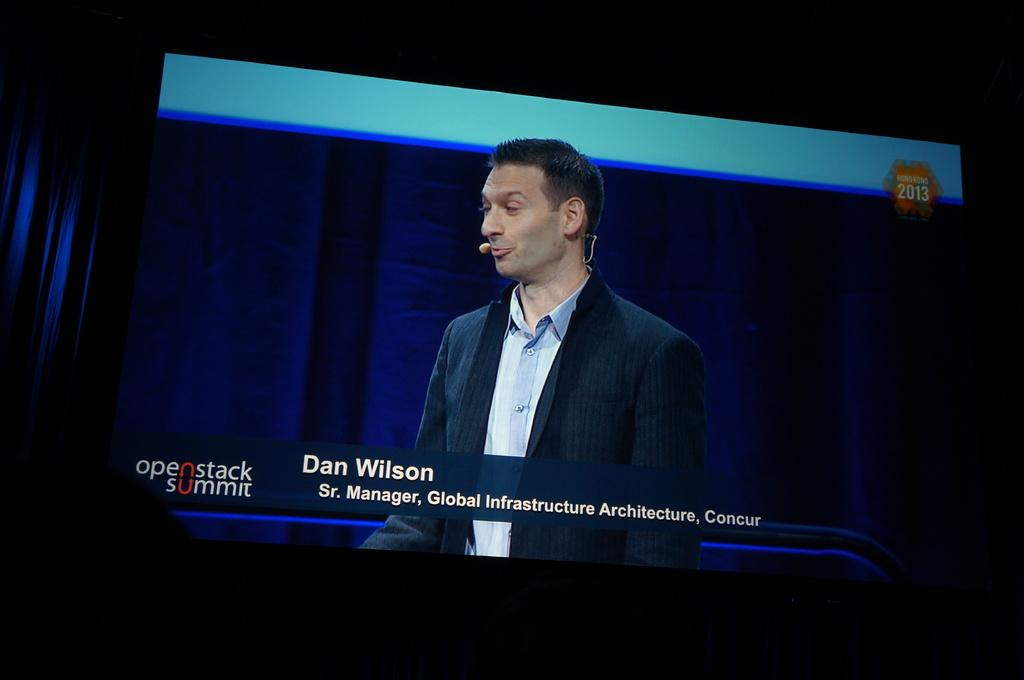What electronic device can be seen in the image? There is a television in the image. What is being displayed on the television screen? A man with a mic is visible on the television screen, along with some text. What is the color of the background in the image? The background of the image is dark. What type of jar is being used to store the man's trousers in the image? There is no jar or trousers present in the image}. 